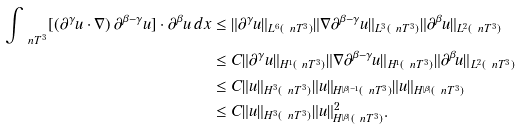Convert formula to latex. <formula><loc_0><loc_0><loc_500><loc_500>\int _ { \ n T ^ { 3 } } [ ( \partial ^ { \gamma } u \cdot \nabla ) \, \partial ^ { \beta - \gamma } u ] \cdot \partial ^ { \beta } u \, d x & \leq \| \partial ^ { \gamma } u \| _ { L ^ { 6 } ( { \ n T ^ { 3 } } ) } \| \nabla \partial ^ { \beta - \gamma } u \| _ { L ^ { 3 } ( { \ n T ^ { 3 } } ) } \| \partial ^ { \beta } u \| _ { L ^ { 2 } ( { \ n T ^ { 3 } } ) } \\ & \leq C \| \partial ^ { \gamma } u \| _ { H ^ { 1 } ( { \ n T ^ { 3 } } ) } \| \nabla \partial ^ { \beta - \gamma } u \| _ { H ^ { 1 } ( { \ n T ^ { 3 } } ) } \| \partial ^ { \beta } u \| _ { L ^ { 2 } ( { \ n T ^ { 3 } } ) } \\ & \leq C \| u \| _ { H ^ { 3 } ( { \ n T ^ { 3 } } ) } \| u \| _ { H ^ { | \beta | - 1 } ( { \ n T ^ { 3 } } ) } \| u \| _ { H ^ { | \beta | } ( { \ n T ^ { 3 } } ) } \\ & \leq C \| u \| _ { H ^ { 3 } ( { \ n T ^ { 3 } } ) } \| u \| _ { H ^ { | \beta | } ( { \ n T ^ { 3 } } ) } ^ { 2 } .</formula> 